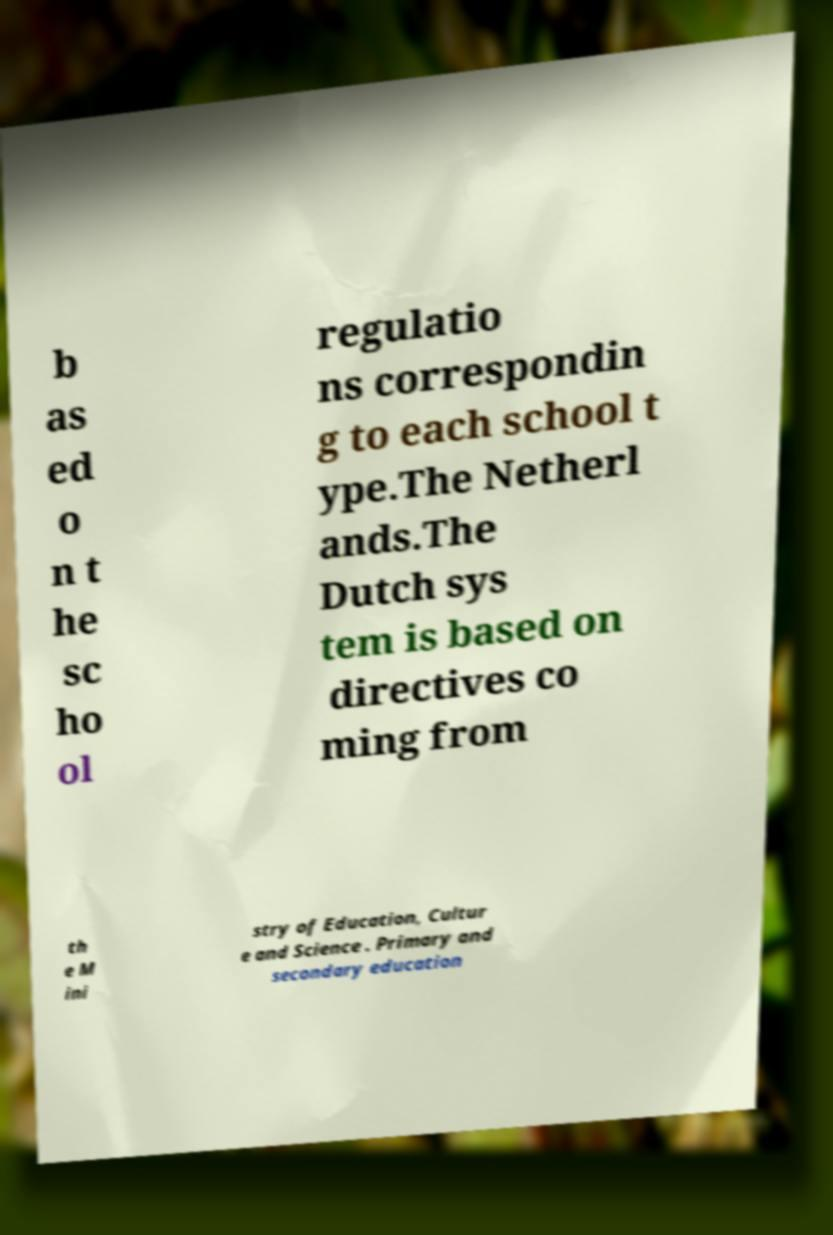There's text embedded in this image that I need extracted. Can you transcribe it verbatim? b as ed o n t he sc ho ol regulatio ns correspondin g to each school t ype.The Netherl ands.The Dutch sys tem is based on directives co ming from th e M ini stry of Education, Cultur e and Science . Primary and secondary education 